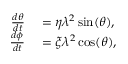<formula> <loc_0><loc_0><loc_500><loc_500>\begin{array} { r l } { \frac { d \theta } { d t } } & = \eta \lambda ^ { 2 } \sin ( \theta ) , } \\ { \frac { d \phi } { d t } } & = \xi \lambda ^ { 2 } \cos ( \theta ) , } \end{array}</formula> 